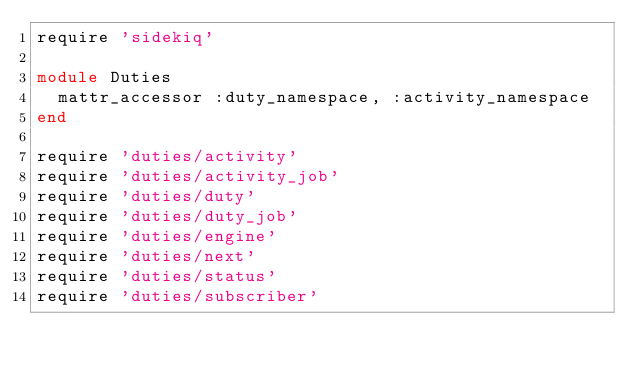<code> <loc_0><loc_0><loc_500><loc_500><_Ruby_>require 'sidekiq'

module Duties
  mattr_accessor :duty_namespace, :activity_namespace
end

require 'duties/activity'
require 'duties/activity_job'
require 'duties/duty'
require 'duties/duty_job'
require 'duties/engine'
require 'duties/next'
require 'duties/status'
require 'duties/subscriber'
</code> 